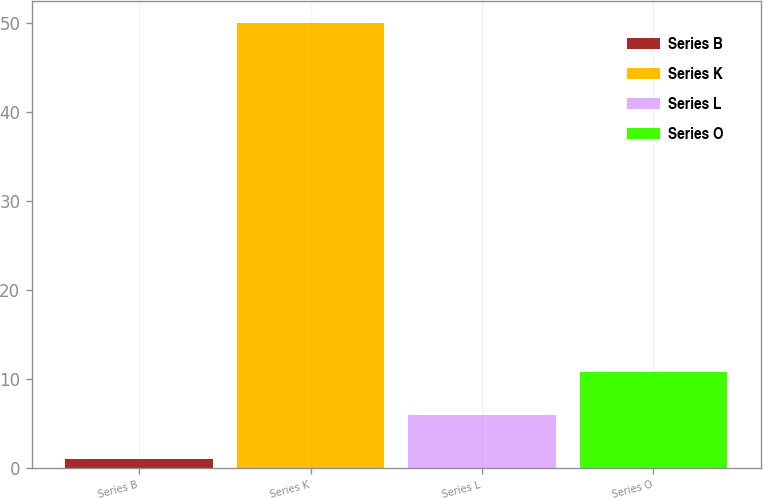<chart> <loc_0><loc_0><loc_500><loc_500><bar_chart><fcel>Series B<fcel>Series K<fcel>Series L<fcel>Series O<nl><fcel>1<fcel>50<fcel>5.9<fcel>10.8<nl></chart> 